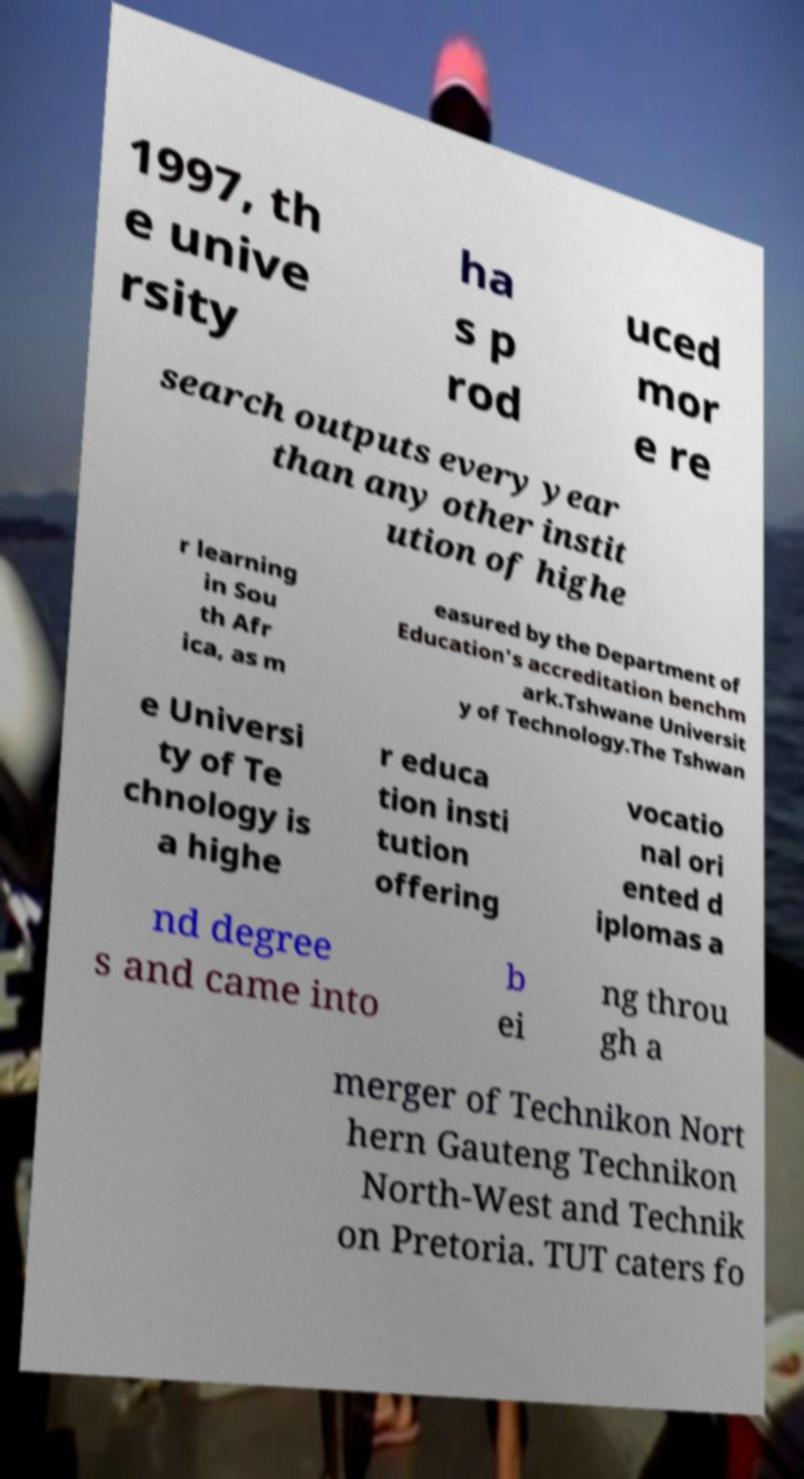Can you accurately transcribe the text from the provided image for me? 1997, th e unive rsity ha s p rod uced mor e re search outputs every year than any other instit ution of highe r learning in Sou th Afr ica, as m easured by the Department of Education's accreditation benchm ark.Tshwane Universit y of Technology.The Tshwan e Universi ty of Te chnology is a highe r educa tion insti tution offering vocatio nal ori ented d iplomas a nd degree s and came into b ei ng throu gh a merger of Technikon Nort hern Gauteng Technikon North-West and Technik on Pretoria. TUT caters fo 